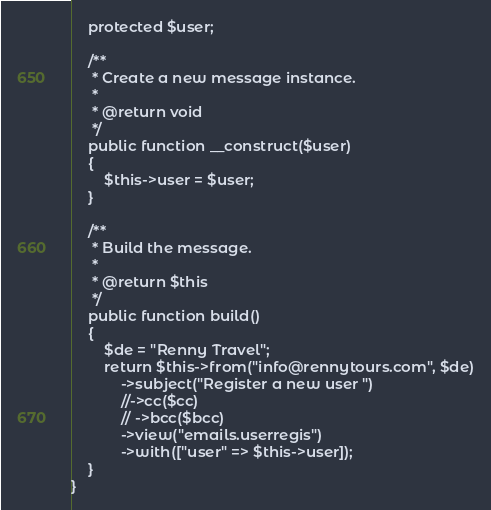<code> <loc_0><loc_0><loc_500><loc_500><_PHP_>    protected $user;

    /**
     * Create a new message instance.
     *
     * @return void
     */
    public function __construct($user)
    {
        $this->user = $user;
    }

    /**
     * Build the message.
     *
     * @return $this
     */
    public function build()
    {
        $de = "Renny Travel";
        return $this->from("info@rennytours.com", $de)
            ->subject("Register a new user ")
            //->cc($cc)
            // ->bcc($bcc)
            ->view("emails.userregis")
            ->with(["user" => $this->user]);
    }
}
</code> 